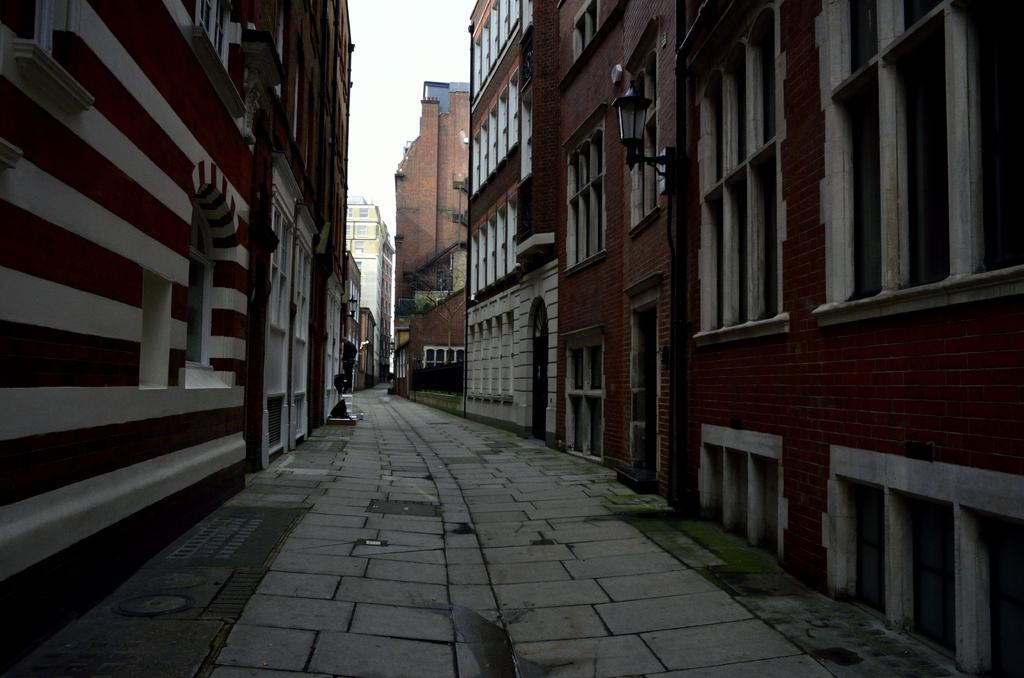What is the main feature of the image? There is a path in the image. What can be seen on either side of the path? There are buildings on either side of the path. What colors are the buildings? The buildings are in brown and white colors. What is visible in the background of the image? There is a sky visible in the background of the image. Can you point out the skirt in the image? There is no skirt present in the image. What example of a bird can be seen in the image? There are no birds visible in the image. 